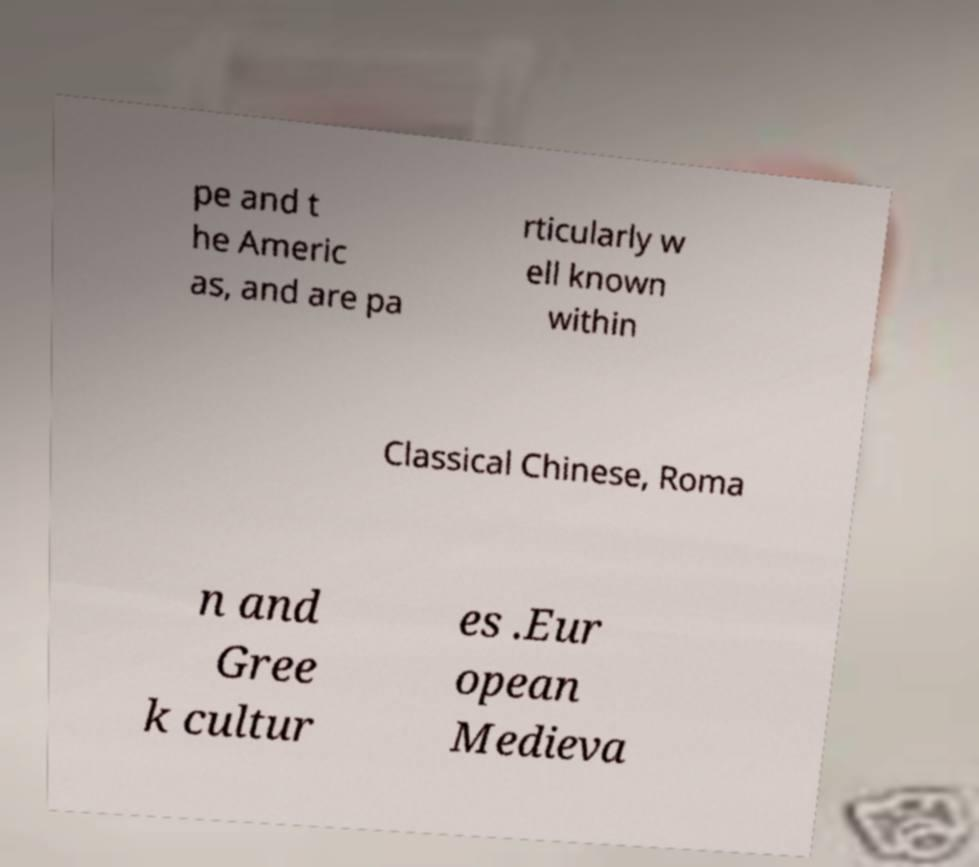Could you assist in decoding the text presented in this image and type it out clearly? pe and t he Americ as, and are pa rticularly w ell known within Classical Chinese, Roma n and Gree k cultur es .Eur opean Medieva 